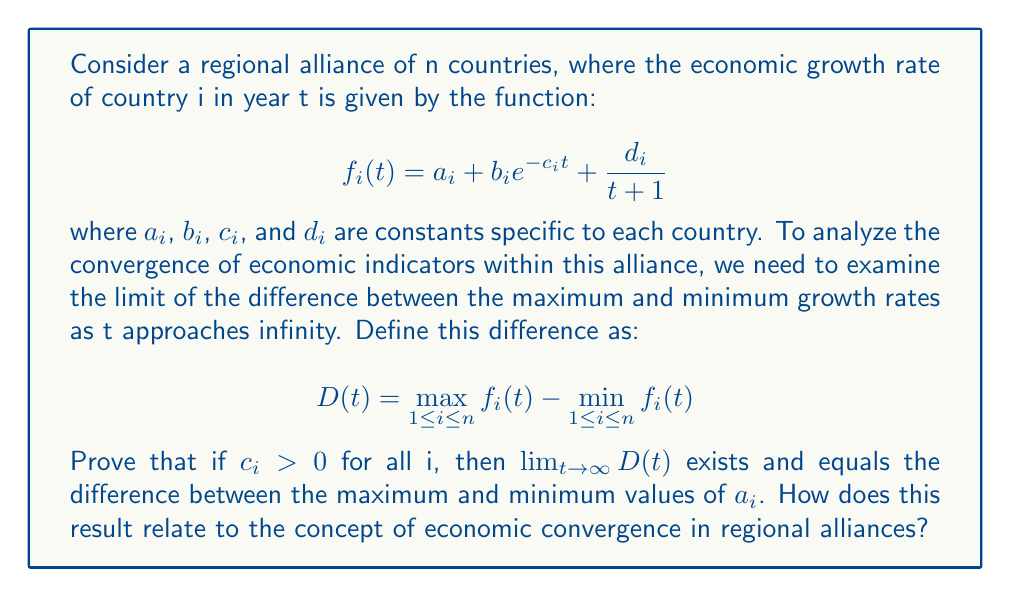Can you answer this question? To prove this, we'll follow these steps:

1) First, let's examine the limit of each country's growth rate function as t approaches infinity:

   $$\lim_{t \to \infty} f_i(t) = \lim_{t \to \infty} (a_i + b_i e^{-c_i t} + \frac{d_i}{t+1})$$

2) We can break this limit into three parts:
   
   a) $\lim_{t \to \infty} a_i = a_i$ (constant)
   
   b) $\lim_{t \to \infty} b_i e^{-c_i t} = 0$ (since $c_i > 0$)
   
   c) $\lim_{t \to \infty} \frac{d_i}{t+1} = 0$

3) Therefore, $\lim_{t \to \infty} f_i(t) = a_i$ for all i.

4) Now, let's consider the limit of D(t):

   $$\lim_{t \to \infty} D(t) = \lim_{t \to \infty} (\max_{1 \leq i \leq n} f_i(t) - \min_{1 \leq i \leq n} f_i(t))$$

5) Since the limit of each $f_i(t)$ is $a_i$, this becomes:

   $$\lim_{t \to \infty} D(t) = \max_{1 \leq i \leq n} a_i - \min_{1 \leq i \leq n} a_i$$

6) This limit exists and equals the difference between the maximum and minimum values of $a_i$.

Relating to economic convergence in regional alliances:

This result suggests that in the long run, the difference in economic growth rates between countries in the alliance converges to the difference in their long-term growth potentials (represented by $a_i$). If all $a_i$ are equal, we have perfect convergence. Otherwise, there remains a persistent difference in growth rates, which could be attributed to structural differences between economies, possibly influenced by geopolitical factors.
Answer: $\lim_{t \to \infty} D(t) = \max_{1 \leq i \leq n} a_i - \min_{1 \leq i \leq n} a_i$ 